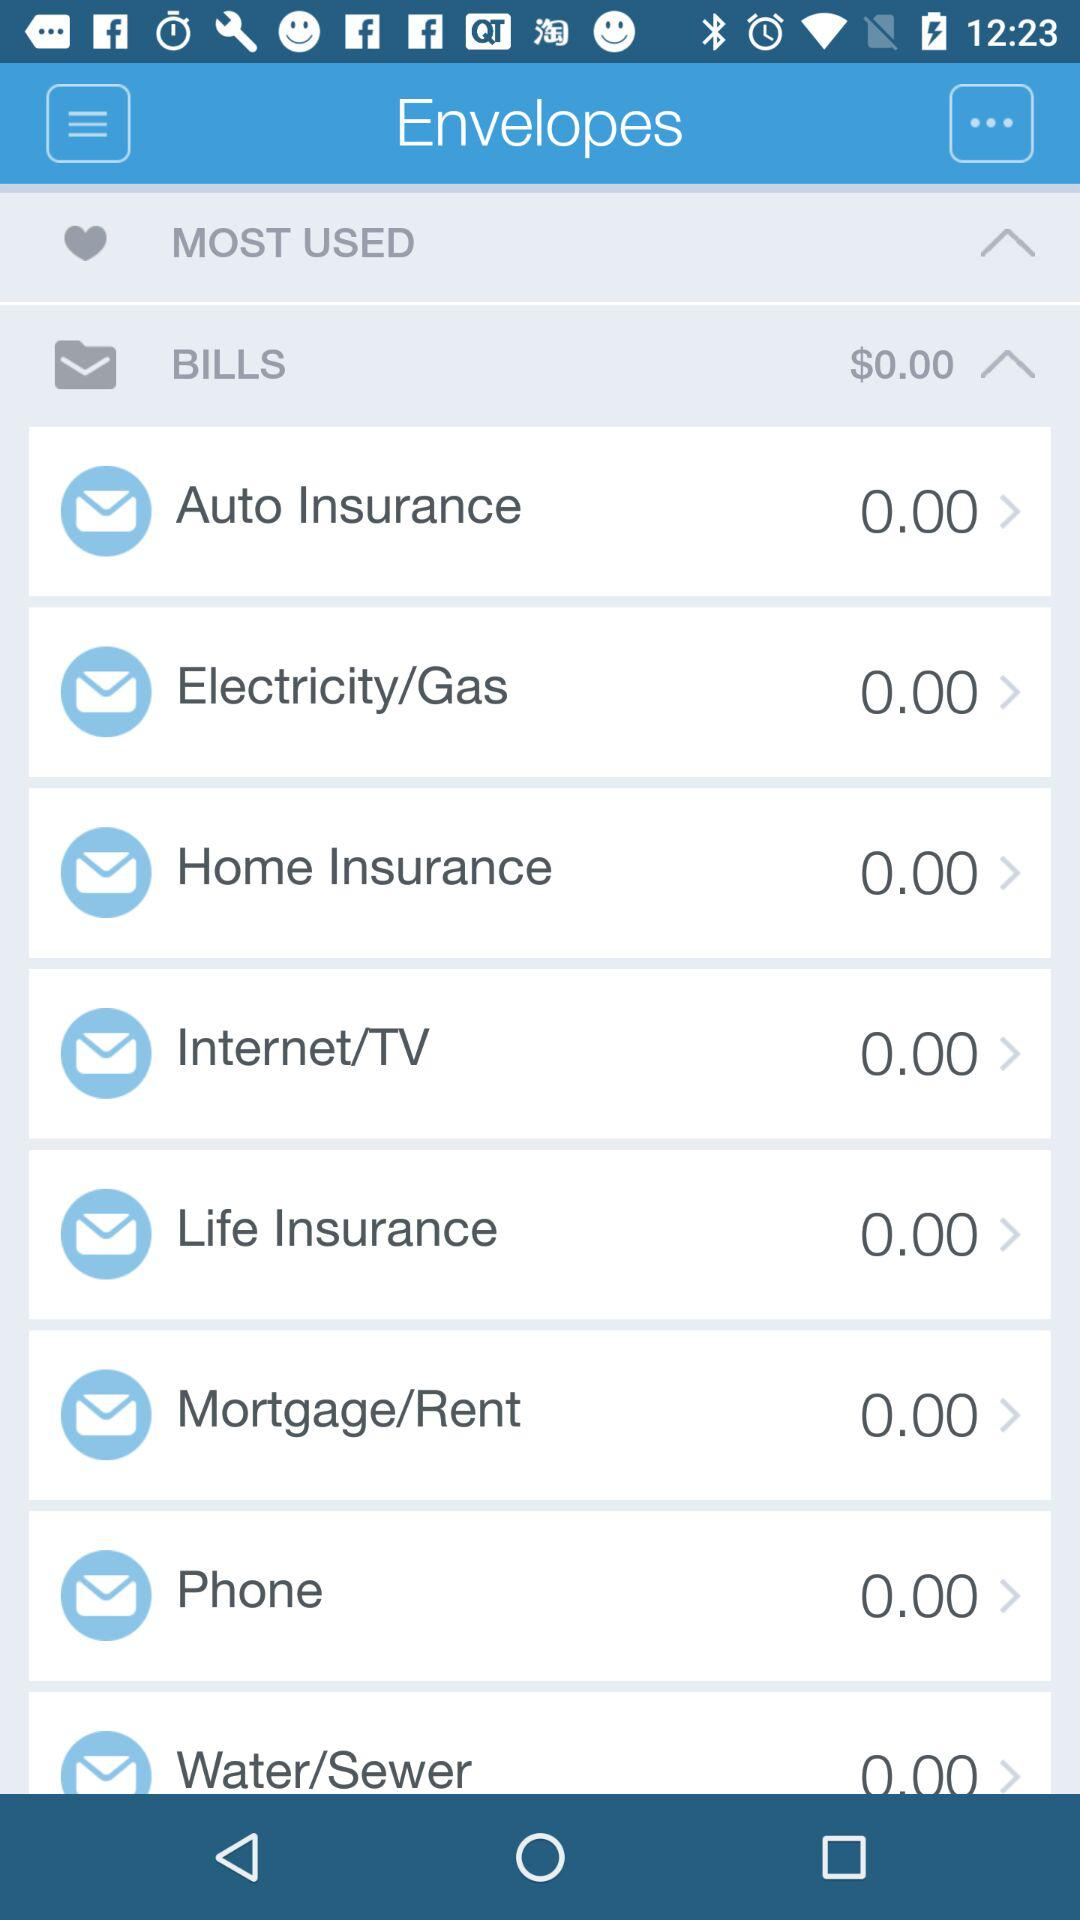How many items have a dollar amount that is greater than 0.00?
Answer the question using a single word or phrase. 0 